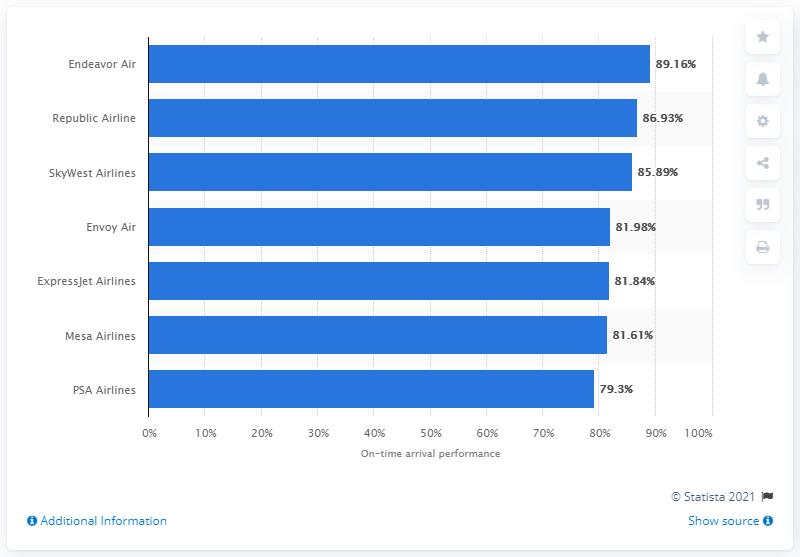Highlight a few significant elements in this photo. Endeavor Air was the most punctual U.S. regional airline in 2020. 